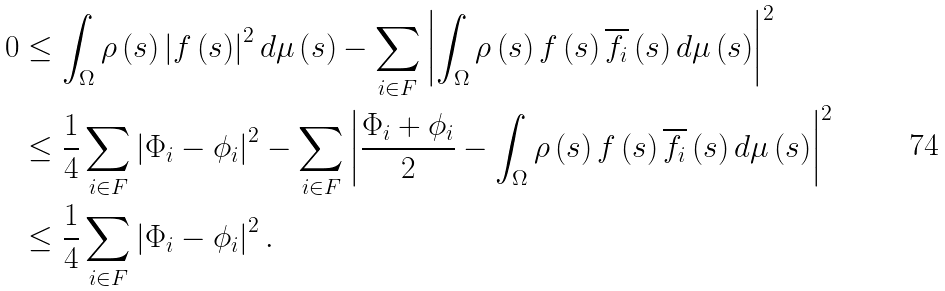<formula> <loc_0><loc_0><loc_500><loc_500>0 & \leq \int _ { \Omega } \rho \left ( s \right ) \left | f \left ( s \right ) \right | ^ { 2 } d \mu \left ( s \right ) - \sum _ { i \in F } \left | \int _ { \Omega } \rho \left ( s \right ) f \left ( s \right ) \overline { f _ { i } } \left ( s \right ) d \mu \left ( s \right ) \right | ^ { 2 } \\ & \leq \frac { 1 } { 4 } \sum _ { i \in F } \left | \Phi _ { i } - \phi _ { i } \right | ^ { 2 } - \sum _ { i \in F } \left | \frac { \Phi _ { i } + \phi _ { i } } { 2 } - \int _ { \Omega } \rho \left ( s \right ) f \left ( s \right ) \overline { f _ { i } } \left ( s \right ) d \mu \left ( s \right ) \right | ^ { 2 } \\ & \leq \frac { 1 } { 4 } \sum _ { i \in F } \left | \Phi _ { i } - \phi _ { i } \right | ^ { 2 } .</formula> 